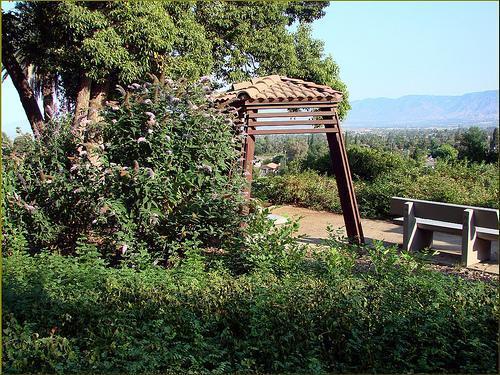How many benches are there?
Give a very brief answer. 1. 